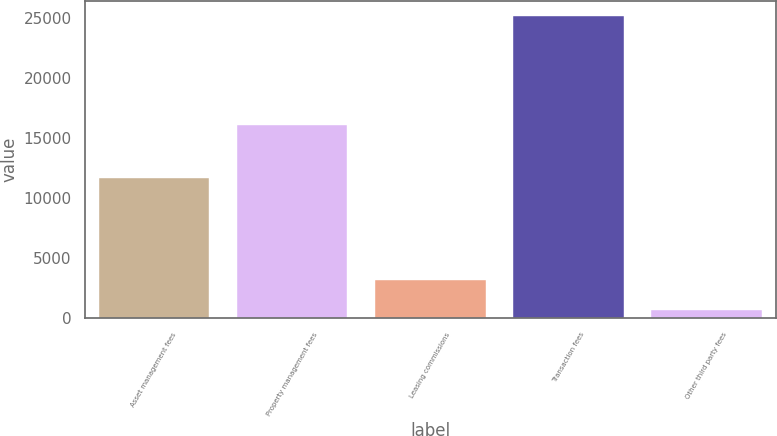Convert chart to OTSL. <chart><loc_0><loc_0><loc_500><loc_500><bar_chart><fcel>Asset management fees<fcel>Property management fees<fcel>Leasing commissions<fcel>Transaction fees<fcel>Other third party fees<nl><fcel>11673<fcel>16132<fcel>3153.6<fcel>25155<fcel>709<nl></chart> 